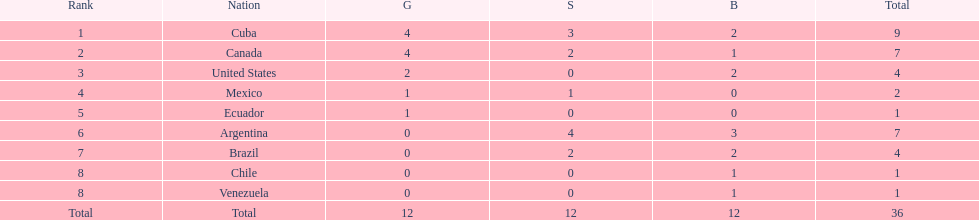Which country won the largest haul of bronze medals? Argentina. 